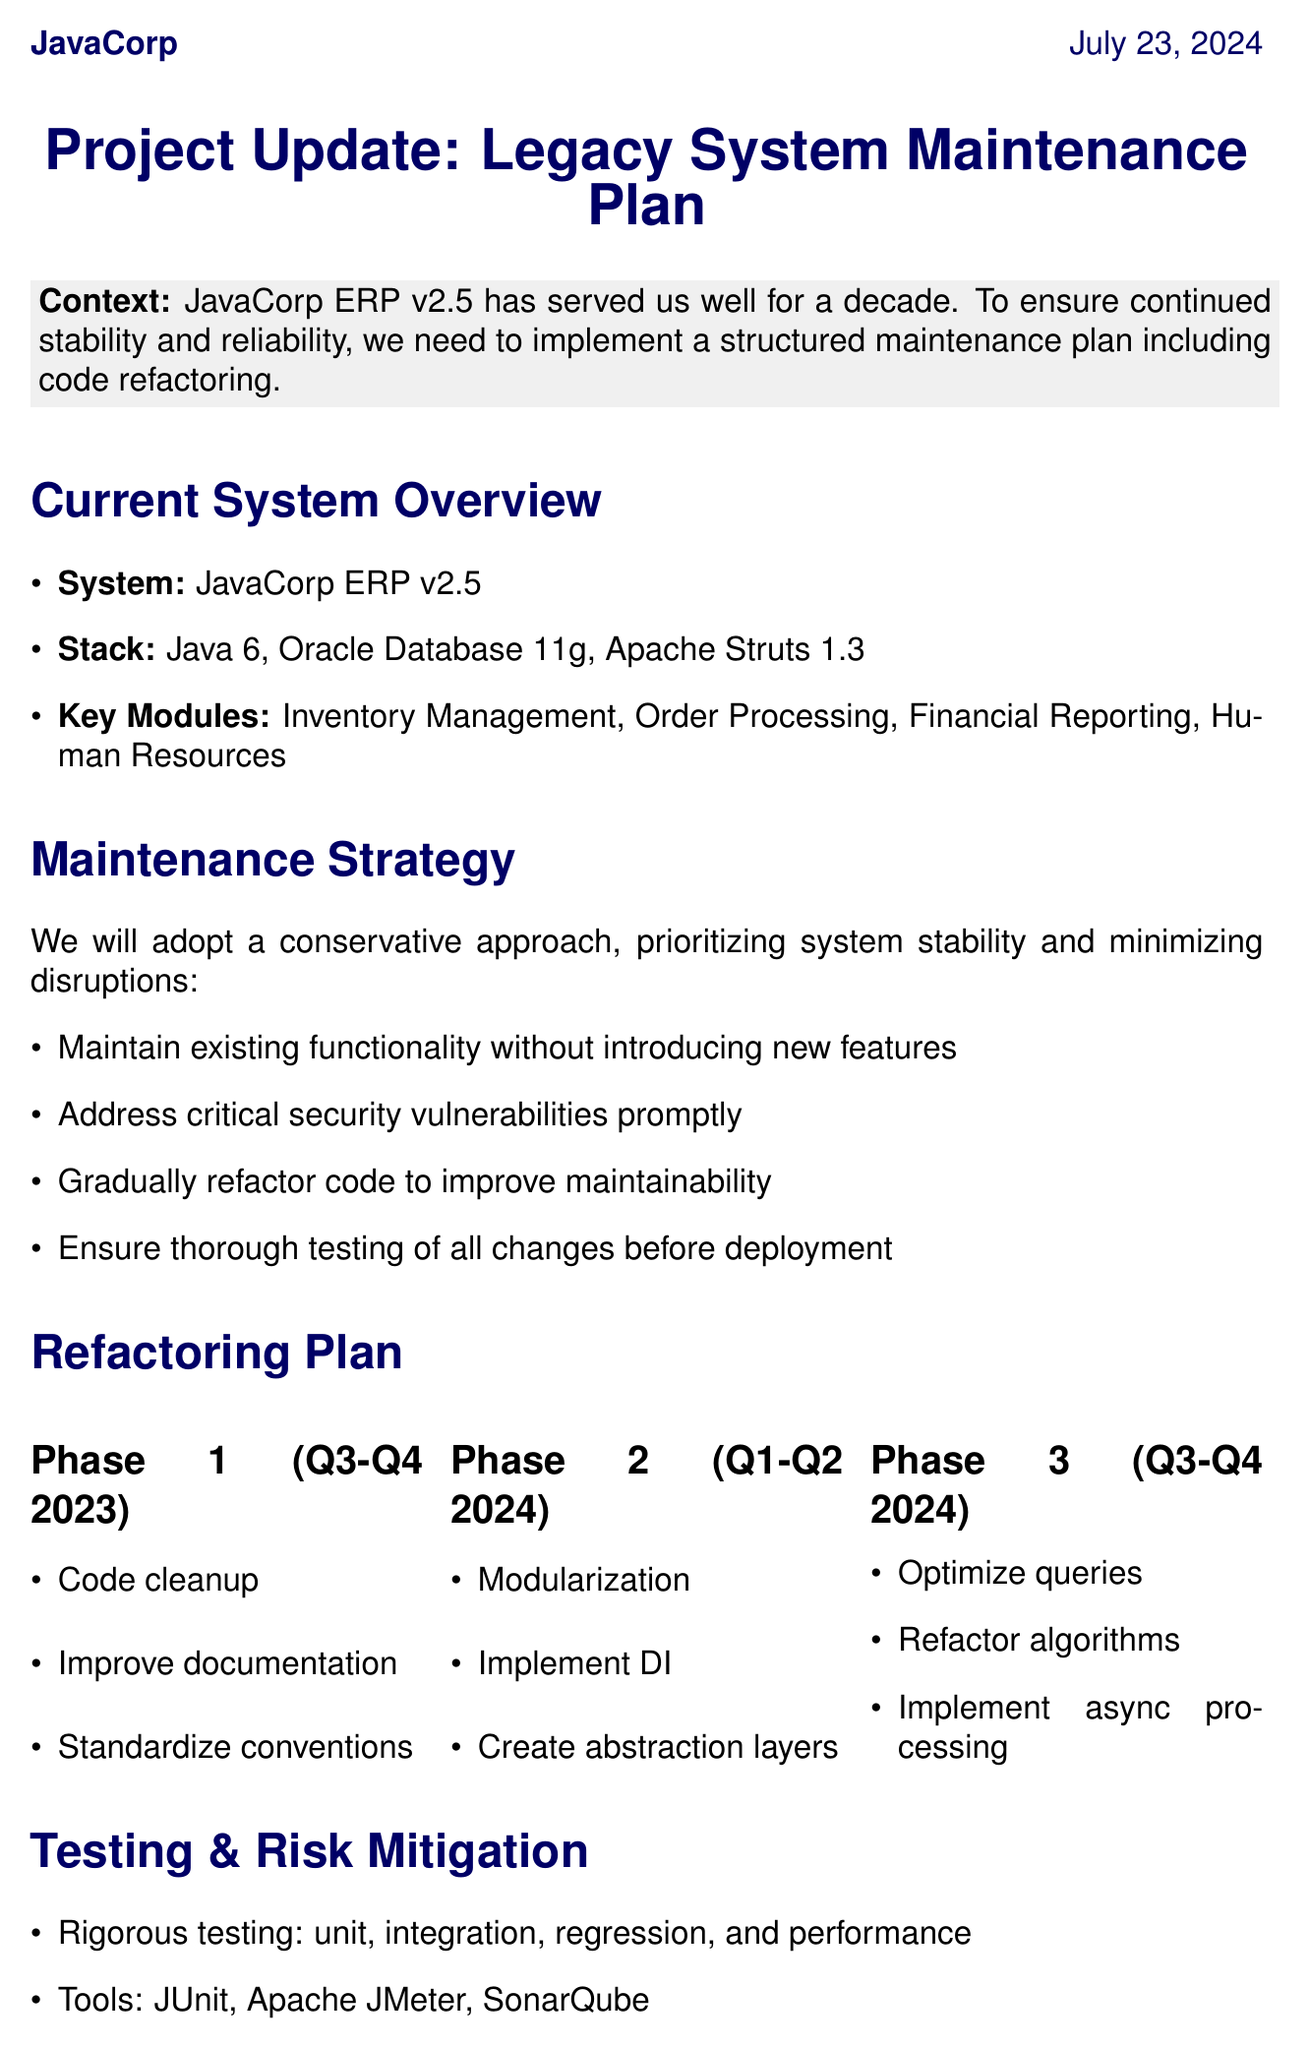What is the name of the legacy system? The document specifically mentions that the legacy system is called "JavaCorp ERP v2.5."
Answer: JavaCorp ERP v2.5 What programming language is used in the current system? The technology stack includes "Java 6" as one of the technologies used in the system.
Answer: Java 6 What phase focuses on performance optimization? According to the document, "Phase 3" is dedicated to performance optimization tasks.
Answer: Phase 3 Who is the lead developer for this project? The resource allocation section identifies "Sarah Chen" as the lead developer.
Answer: Sarah Chen When is the first phase of refactoring scheduled to occur? The timeline for Phase 1 is indicated as "Q3 2023 - Q4 2023."
Answer: Q3 2023 - Q4 2023 What is the approach to testing? The document outlines that a "rigorous testing" approach will be used, including various types of tests.
Answer: Rigorous testing What is the main objective of this maintenance plan? The introductory section states that the objective is to maintain the legacy system while improving its codebase through refactoring.
Answer: To maintain the legacy system while improving its codebase How often will stakeholder updates be provided? The communication plan mentions that stakeholder updates will occur "bi-weekly."
Answer: Bi-weekly What tools are mentioned for testing purposes? The document lists "JUnit," "Apache JMeter," and "SonarQube" as the tools to be used for testing.
Answer: JUnit, Apache JMeter, SonarQube 